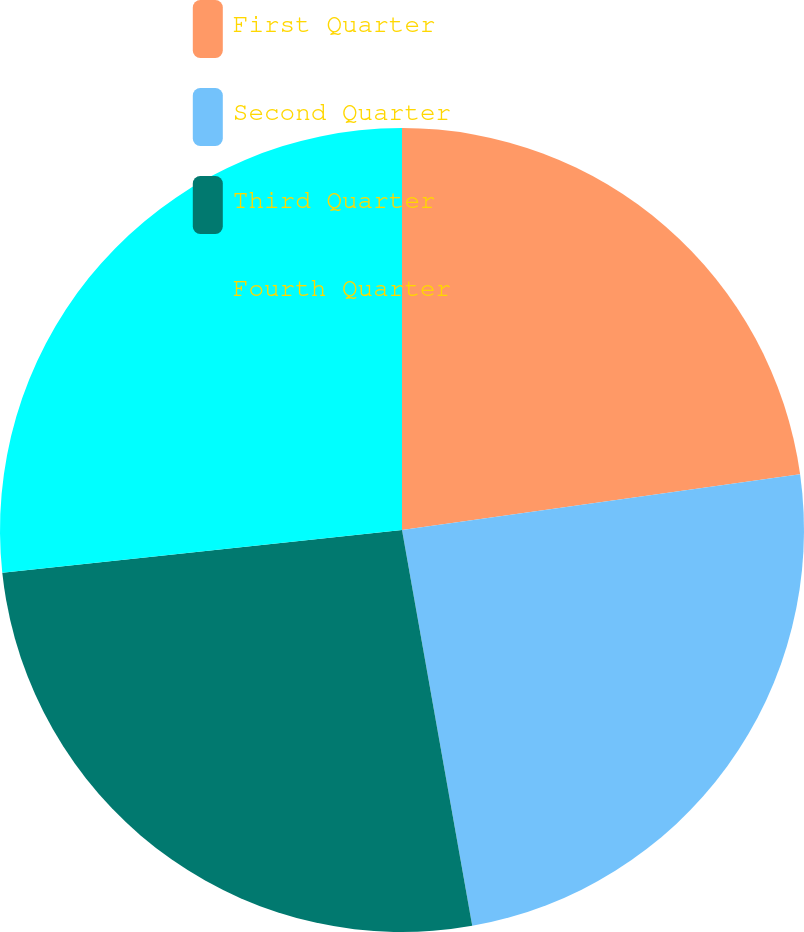Convert chart. <chart><loc_0><loc_0><loc_500><loc_500><pie_chart><fcel>First Quarter<fcel>Second Quarter<fcel>Third Quarter<fcel>Fourth Quarter<nl><fcel>22.79%<fcel>24.42%<fcel>26.1%<fcel>26.7%<nl></chart> 